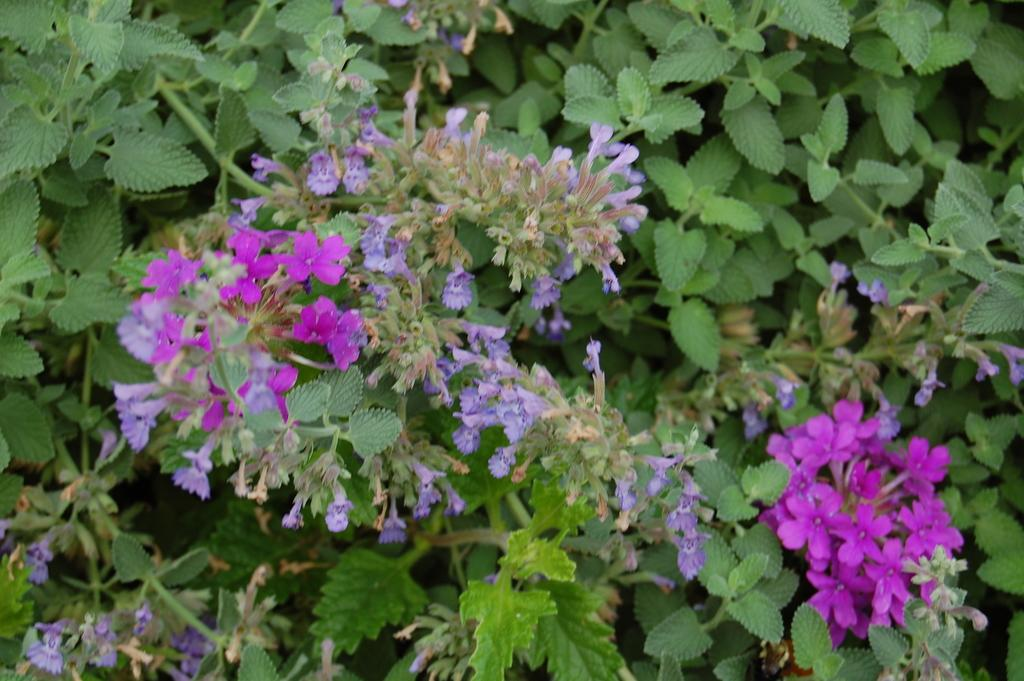What type of image is being shown? The image is a zoomed in picture. What can be seen in the foreground of the image? There are flowers and leaves of plants in the foreground of the image. How many stamps are visible on the flowers in the image? There are no stamps present on the flowers in the image. Can you see a baby playing with the leaves in the image? There is no baby present in the image; it only features flowers and leaves of plants. 